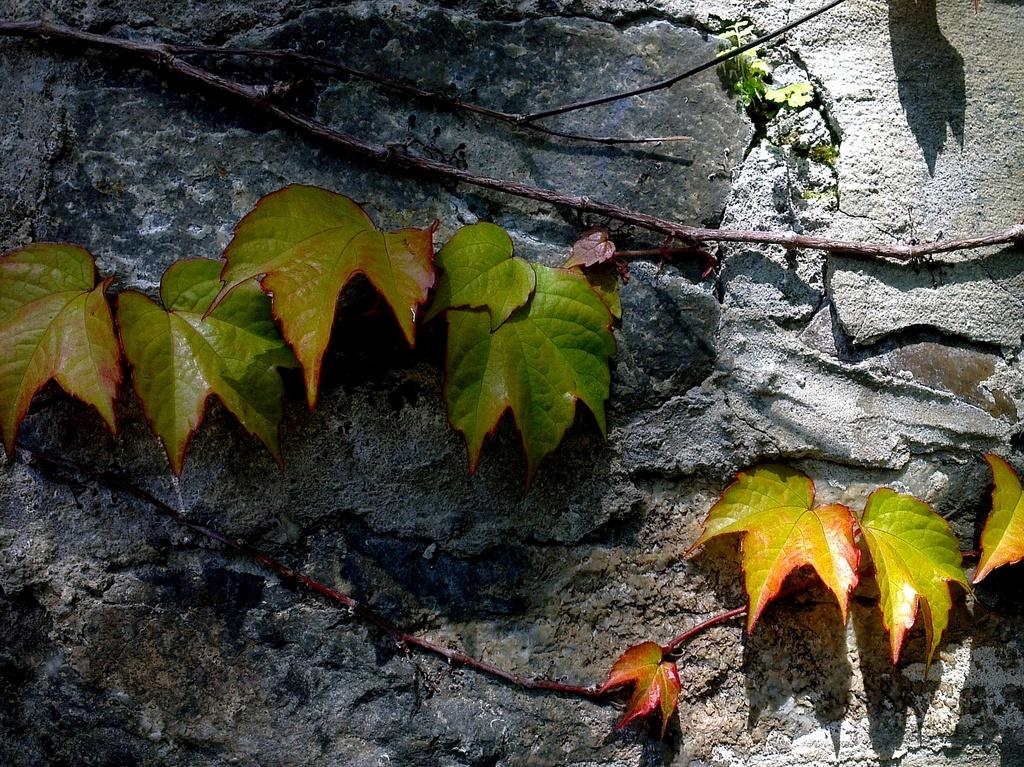What type of plant material can be seen in the image? There are leaves and stems in the image. Where are the leaves and stems located? The leaves and stems are on a rock surface. What color is the ink used to write on the leaves in the image? There is no ink or writing present on the leaves in the image. 